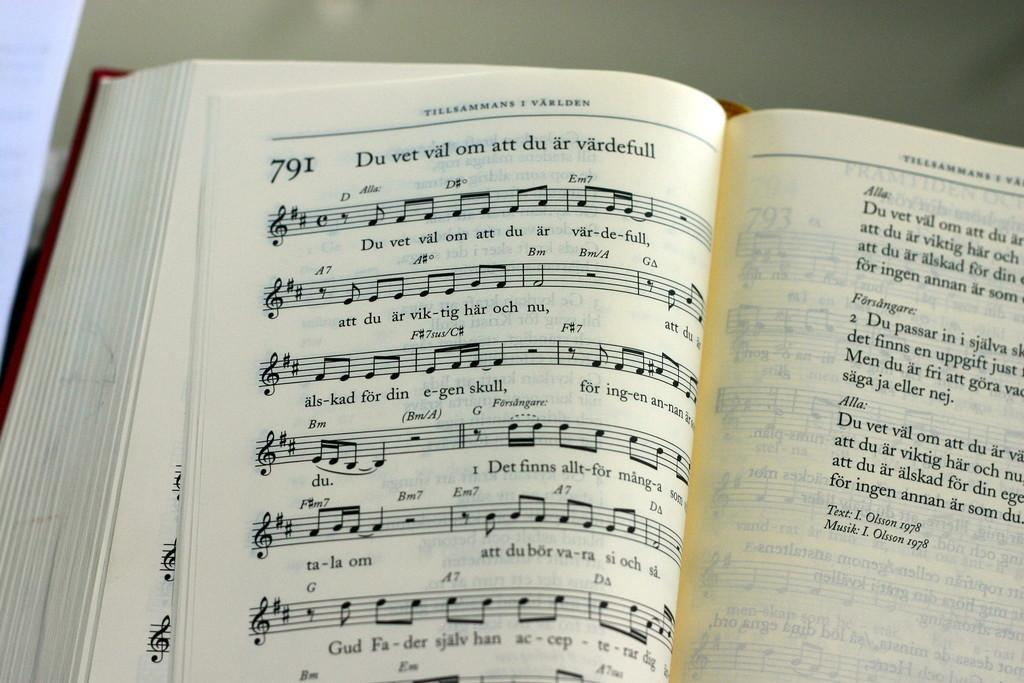<image>
Render a clear and concise summary of the photo. An open very thick hardback German music manuscript book shows song number 791. 